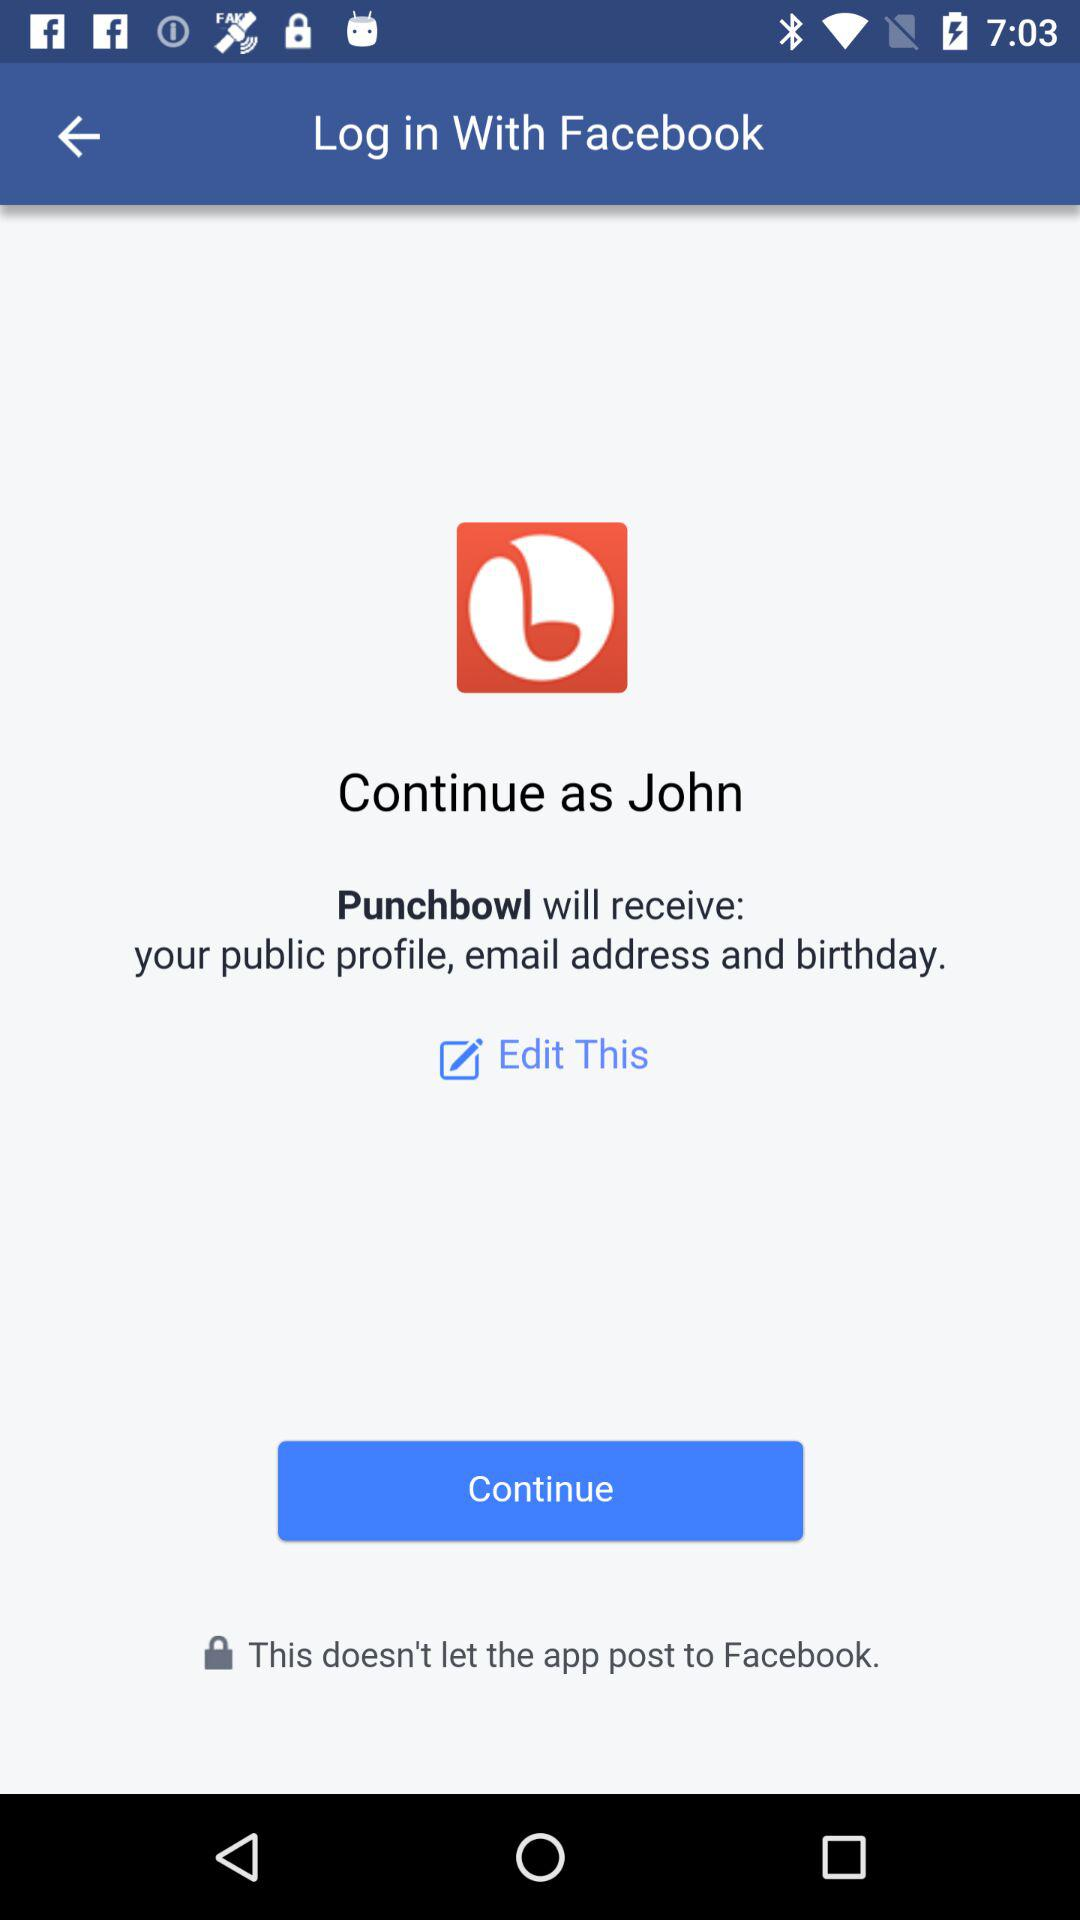What is the application name? The application name is "Facebook". 